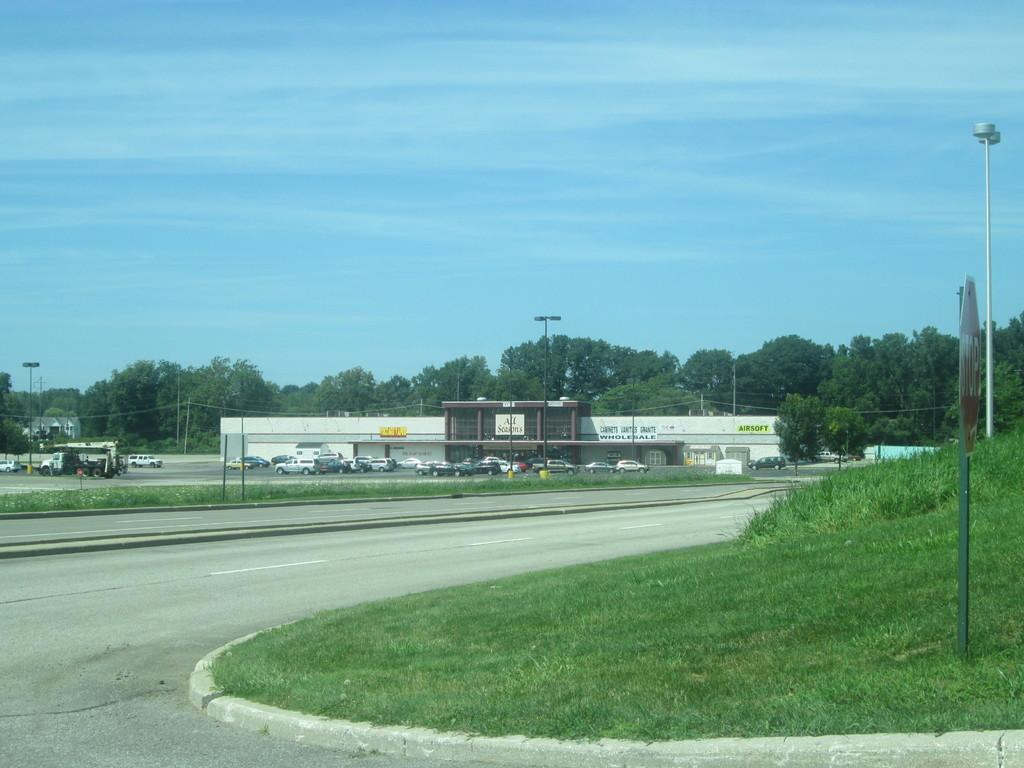What types of objects can be seen in the image? There are vehicles visible in the image. Where are the vehicles located in relation to other objects? The vehicles are near a building. What type of natural environment is visible in the image? There is grass visible in the image. What type of canvas is being used to paint the cactus in the image? There is no canvas or cactus present in the image; it features vehicles near a building and grass. 